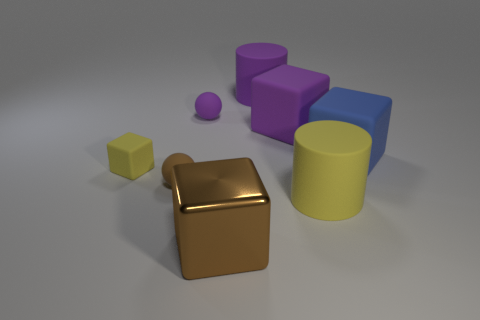Is the number of large brown things that are behind the yellow cylinder the same as the number of objects to the left of the purple cylinder?
Your answer should be compact. No. Does the brown object behind the large brown shiny thing have the same size as the matte block that is left of the purple cube?
Offer a terse response. Yes. There is a thing in front of the big yellow cylinder right of the brown object that is on the left side of the shiny block; what shape is it?
Your answer should be compact. Cube. Is there any other thing that is made of the same material as the blue block?
Provide a short and direct response. Yes. The other yellow object that is the same shape as the big metallic object is what size?
Provide a succinct answer. Small. What color is the matte object that is behind the brown matte ball and to the left of the purple matte ball?
Ensure brevity in your answer.  Yellow. Does the large blue block have the same material as the large purple object left of the big purple cube?
Offer a very short reply. Yes. Is the number of big brown shiny objects that are in front of the metal thing less than the number of big blocks?
Your answer should be very brief. Yes. What number of other objects are there of the same shape as the metallic thing?
Keep it short and to the point. 3. Is there anything else that has the same color as the small block?
Ensure brevity in your answer.  Yes. 